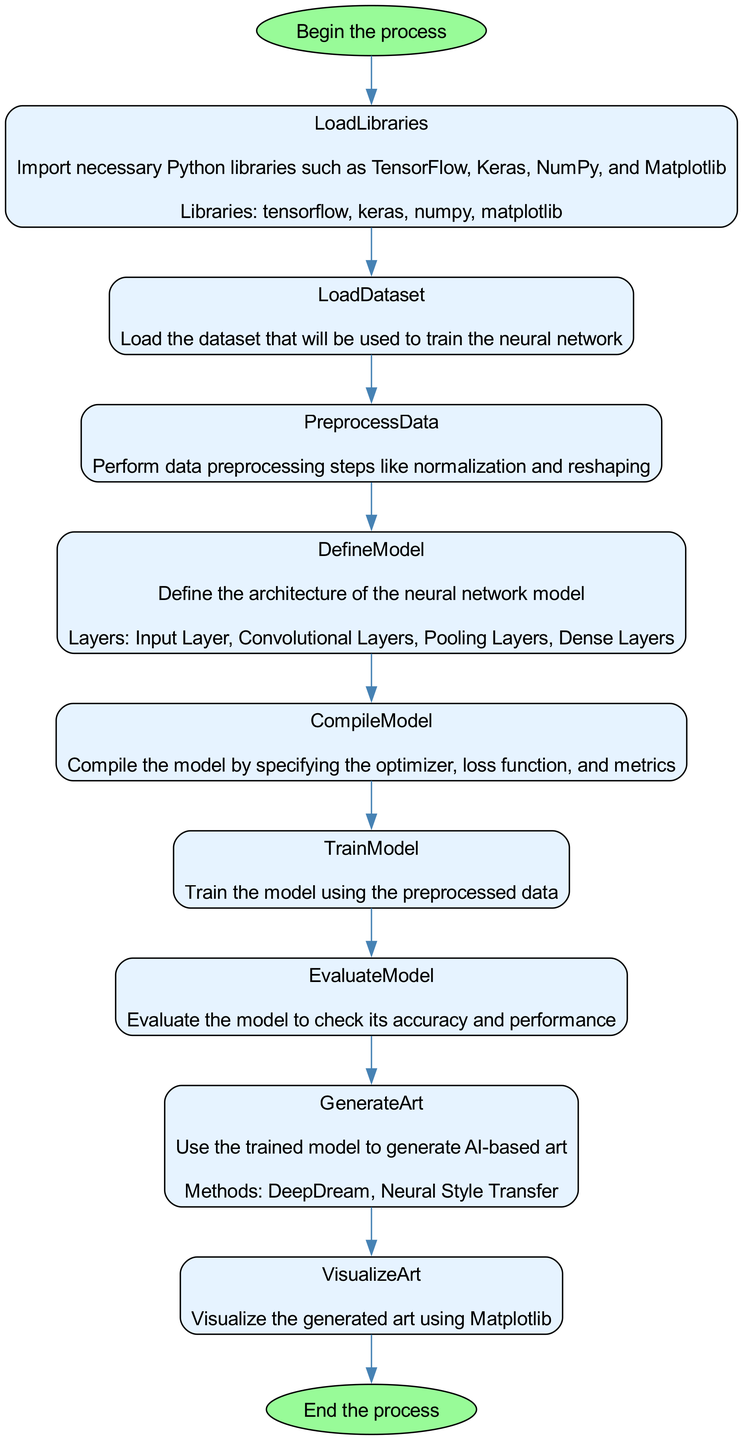What is the first step in the process? The diagram starts with a node labeled "Start," indicating the first step in the process is to "Begin the process."
Answer: Begin the process How many libraries are mentioned in the LoadLibraries step? The "LoadLibraries" step lists four libraries: TensorFlow, Keras, NumPy, and Matplotlib. Therefore, the answer is determined by counting these libraries.
Answer: 4 What is the purpose of the "CompileModel" step? The "CompileModel" step description indicates that it is for compiling the model by specifying the optimizer, loss function, and metrics. This gives us the overall function of the step.
Answer: Compile the model Which method is used to visualize the generated art? In the "VisualizeArt" step, it specifies the tools used to visualize the generated art, which include "plt.imshow" and "plt.show." This indicates the specific method/tool involved in the visualization process.
Answer: plt.imshow, plt.show What is the last step in the diagram? The final step in the process is indicated by the "End" node, which concludes the flowchart. Since the question is about the last step, we refer to this concluding point in the flow.
Answer: End the process How many layers are defined in the DefineModel step? The "DefineModel" step lists four layers: Input Layer, Convolutional Layers, Pooling Layers, and Dense Layers. Thus, the answer is found by counting these layers.
Answer: 4 What is the optimizer used in the CompileModel step? The "CompileModel" step specifically states that the optimizer used is "adam." By reading the description, we can directly answer this question.
Answer: adam What are the two methods listed for generating AI-based art? The "GenerateArt" step lists two methods: DeepDream and Neural Style Transfer. To answer, we simply note these specific methods mentioned.
Answer: DeepDream, Neural Style Transfer 